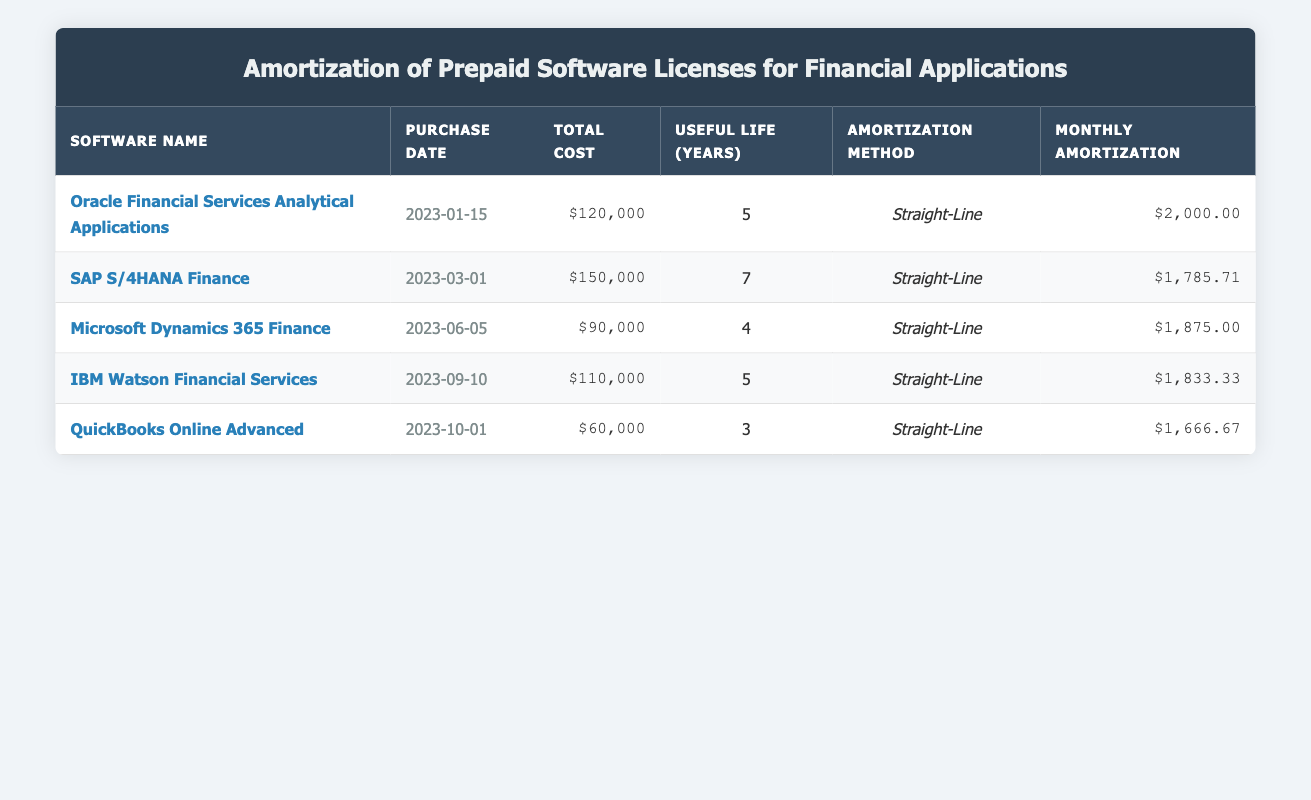What is the total cost of SAP S/4HANA Finance? The total cost is presented in the respective column for each software license. For SAP S/4HANA Finance, the total cost is listed as $150,000.
Answer: $150,000 What is the monthly amortization for Microsoft Dynamics 365 Finance? The monthly amortization is directly listed in the table under the "Monthly Amortization" column. For Microsoft Dynamics 365 Finance, the amount is $1,875.
Answer: $1,875 Which software has the shortest useful life? By examining the "Useful Life (Years)" column, we can see that QuickBooks Online Advanced has a useful life of 3 years, which is less than any other software in the table.
Answer: QuickBooks Online Advanced Is the amortization method for all softwares the same? Checking the "Amortization Method" column for each entry shows that all items are using the "Straight-Line" method, confirming the uniformity in the approach to amortization.
Answer: Yes What is the average monthly amortization for the five software licenses? To calculate the average, we sum the monthly amortization amounts: $2,000 + $1,785.71 + $1,875 + $1,833.33 + $1,666.67 = $9,160.71. There are 5 licenses, so dividing by 5 gives us an average of $1,832.14.
Answer: $1,832.14 What is the total remaining value of all software licenses? The "Remaining Value" for each software license is listed as $0. Adding these together (0 + 0 + 0 + 0 + 0) gives a total remaining value of $0.
Answer: $0 Which software will have its full cost amortized by the end of 2023? To determine this, we need to look at the purchase date and amortization period. The purchase dates of Oracle Financial Services Analytical Applications and Microsoft Dynamics 365 Finance show they will achieve full amortization by the end of 2023 due to their useful lives being 5 years and 4 years, respectively. The other software licenses purchased later won’t reach full amortization by then.
Answer: Oracle Financial Services Analytical Applications, Microsoft Dynamics 365 Finance What is the total cost of all software licenses? Adding together the total costs for each software yields: $120,000 + $150,000 + $90,000 + $110,000 + $60,000 = $530,000, giving the total cost for all licenses.
Answer: $530,000 Which software has the highest monthly amortization? By comparing the monthly amortization figures, we see that Oracle Financial Services Analytical Applications has the highest monthly amortization at $2,000.
Answer: Oracle Financial Services Analytical Applications 